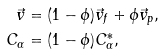Convert formula to latex. <formula><loc_0><loc_0><loc_500><loc_500>\vec { v } & = ( 1 - \phi ) \vec { v } _ { f } + \phi \vec { v } _ { p } , \\ C _ { \alpha } & = ( 1 - \phi ) C _ { \alpha } ^ { * } ,</formula> 